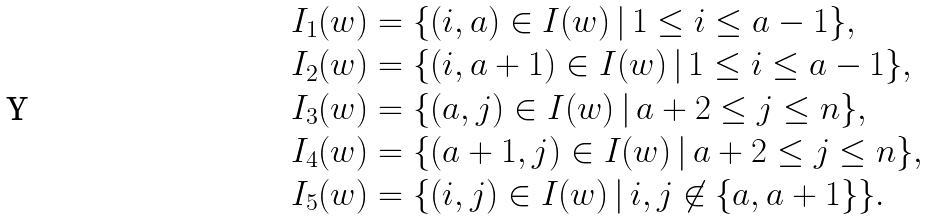Convert formula to latex. <formula><loc_0><loc_0><loc_500><loc_500>I _ { 1 } ( w ) & = \{ ( i , a ) \in I ( w ) \, | \, 1 \leq i \leq a - 1 \} , \\ I _ { 2 } ( w ) & = \{ ( i , a + 1 ) \in I ( w ) \, | \, 1 \leq i \leq a - 1 \} , \\ I _ { 3 } ( w ) & = \{ ( a , j ) \in I ( w ) \, | \, a + 2 \leq j \leq n \} , \\ I _ { 4 } ( w ) & = \{ ( a + 1 , j ) \in I ( w ) \, | \, a + 2 \leq j \leq n \} , \\ I _ { 5 } ( w ) & = \{ ( i , j ) \in I ( w ) \, | \, i , j \not \in \{ a , a + 1 \} \} .</formula> 